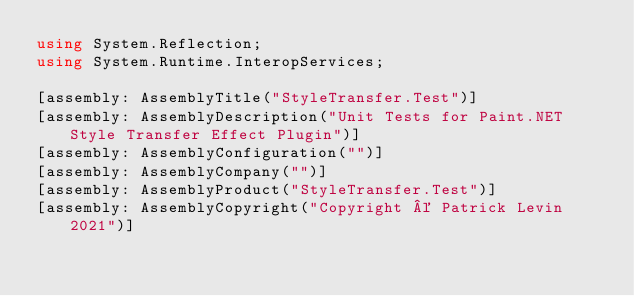Convert code to text. <code><loc_0><loc_0><loc_500><loc_500><_C#_>using System.Reflection;
using System.Runtime.InteropServices;

[assembly: AssemblyTitle("StyleTransfer.Test")]
[assembly: AssemblyDescription("Unit Tests for Paint.NET Style Transfer Effect Plugin")]
[assembly: AssemblyConfiguration("")]
[assembly: AssemblyCompany("")]
[assembly: AssemblyProduct("StyleTransfer.Test")]
[assembly: AssemblyCopyright("Copyright © Patrick Levin 2021")]</code> 